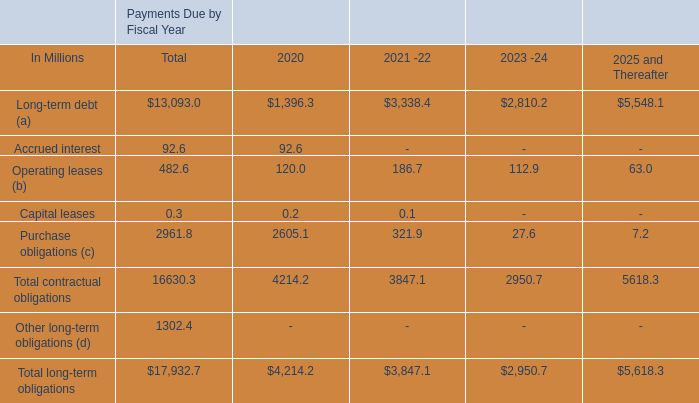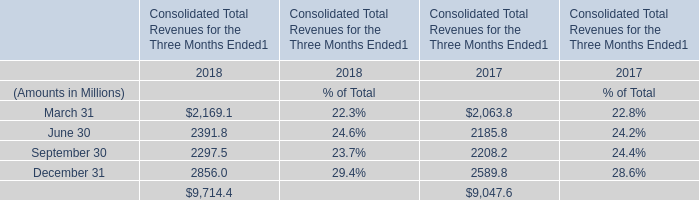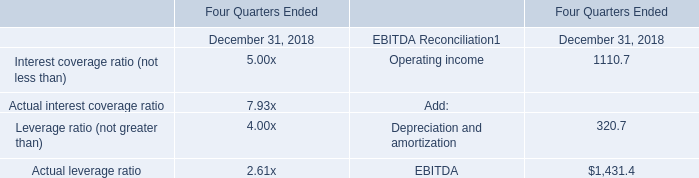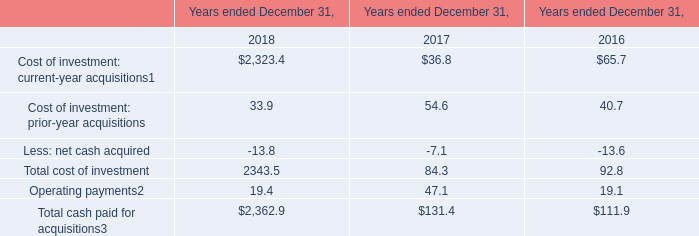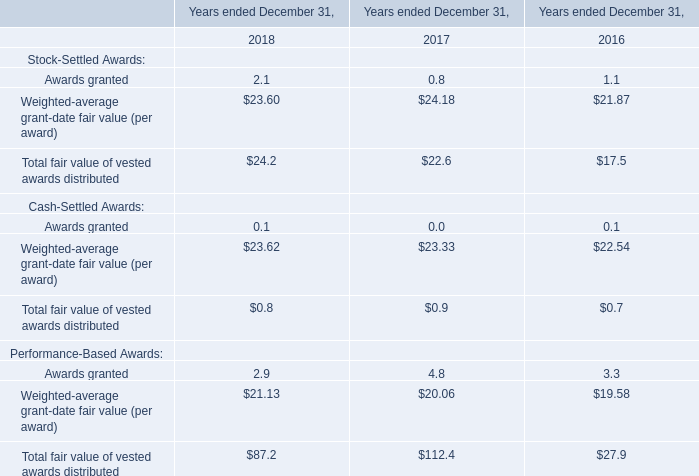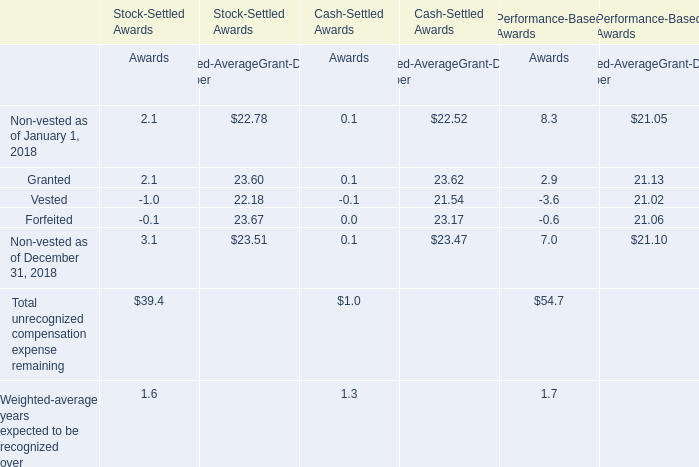What is the sum of Awards granted, Weighted-average grant-date fair value (per award) and Total fair value of vested awards distributed of Stock-Settled Awards in 2018 ? 
Computations: ((2.1 + 23.60) + 24.2)
Answer: 49.9. 